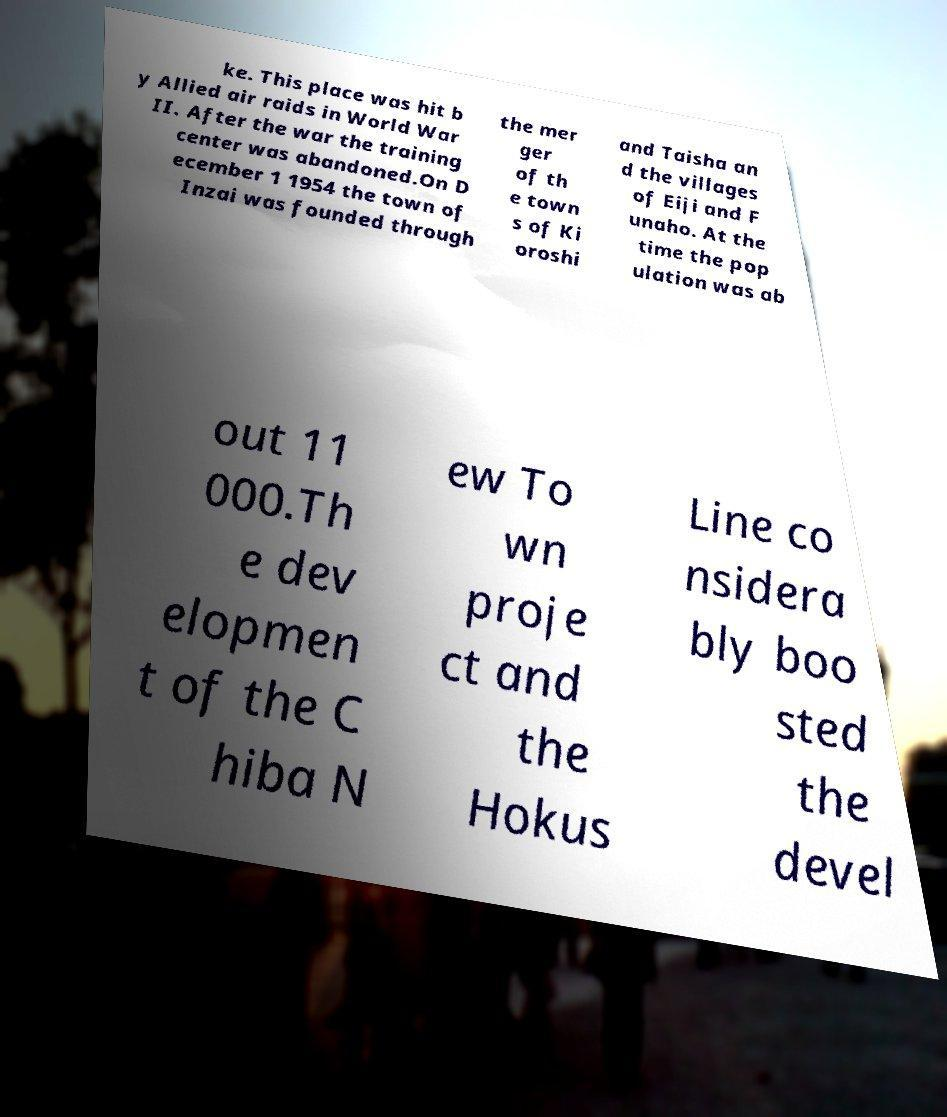Could you extract and type out the text from this image? ke. This place was hit b y Allied air raids in World War II. After the war the training center was abandoned.On D ecember 1 1954 the town of Inzai was founded through the mer ger of th e town s of Ki oroshi and Taisha an d the villages of Eiji and F unaho. At the time the pop ulation was ab out 11 000.Th e dev elopmen t of the C hiba N ew To wn proje ct and the Hokus Line co nsidera bly boo sted the devel 